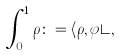Convert formula to latex. <formula><loc_0><loc_0><loc_500><loc_500>\int _ { 0 } ^ { 1 } \rho \colon = \langle \rho , \varphi \rangle ,</formula> 